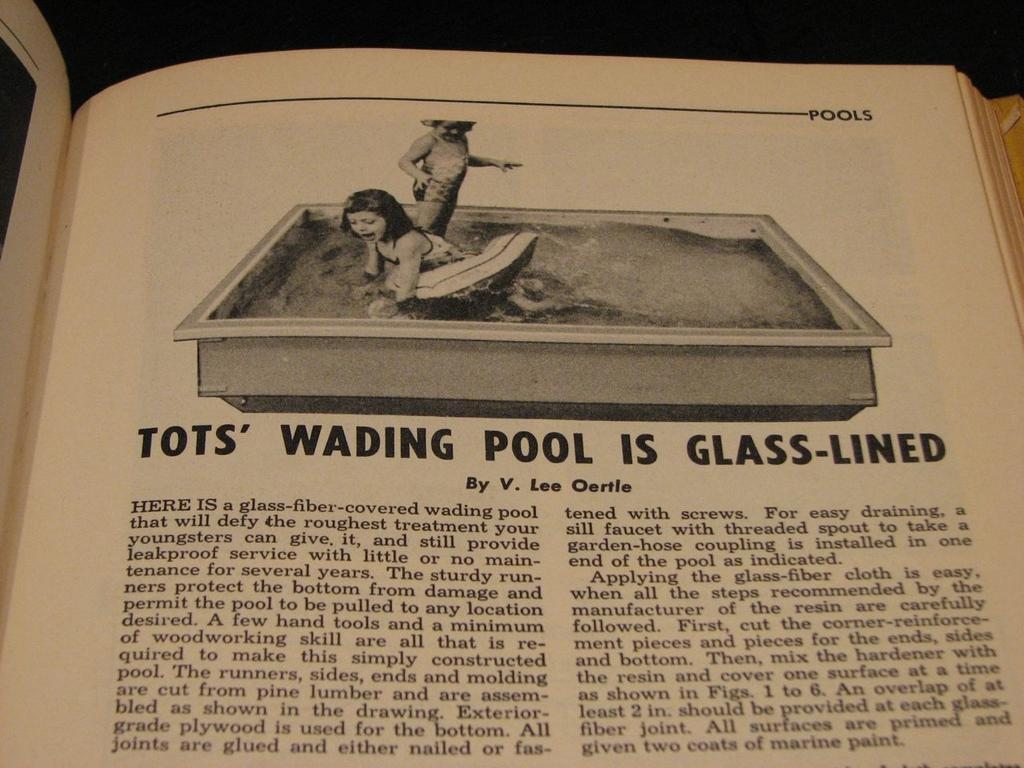What is depicted on the paper in the image? There is a paper with an image of two kids in the picture. What other elements are included in the image besides the paper? The image also includes water and a bathtub. Are there any words on the paper? Yes, there are words written on the paper. How would you describe the overall appearance of the image? The background of the image is dark. What month is the duck celebrating in the image? There is no duck present in the image, so it is not possible to determine which month the duck might be celebrating. 